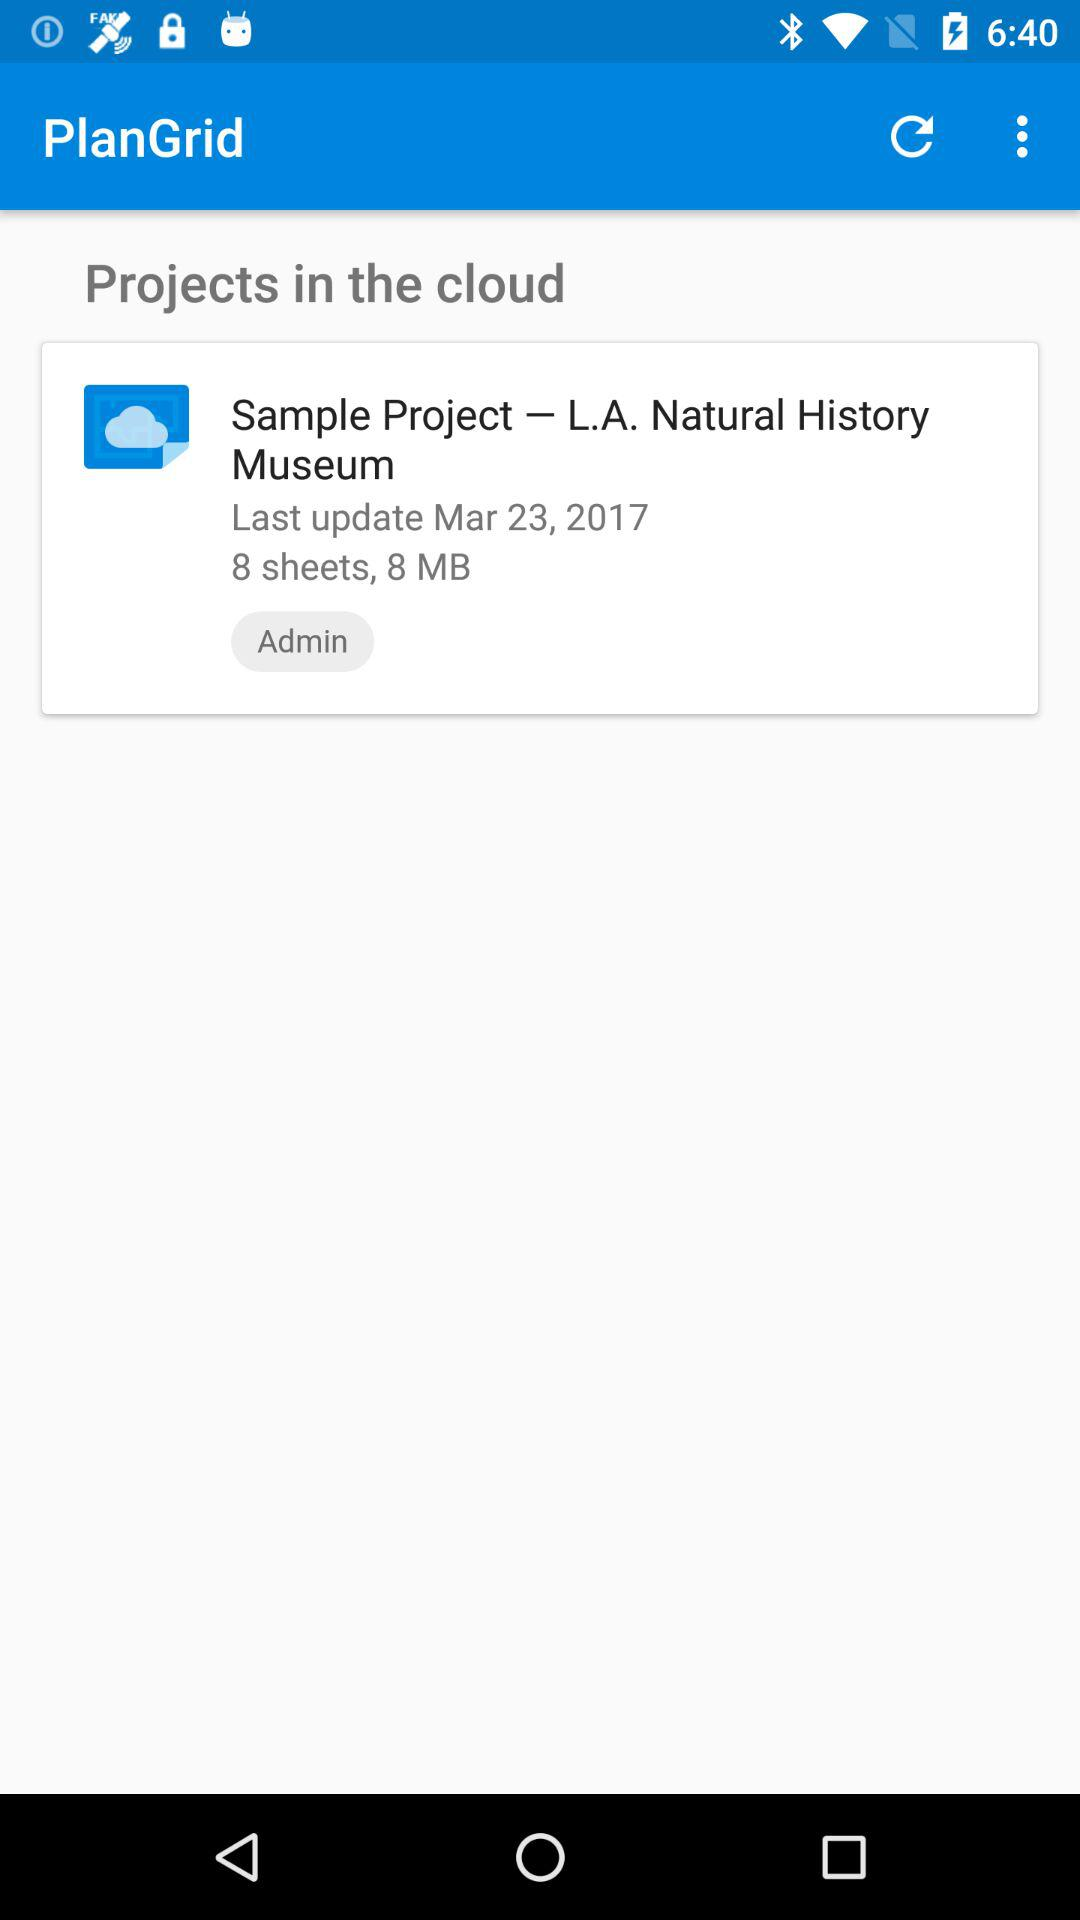How many sheets are there in the sample project? There are 8 sheets in the sample project. 